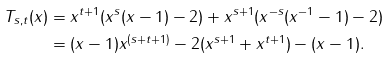Convert formula to latex. <formula><loc_0><loc_0><loc_500><loc_500>T _ { s , t } ( x ) & = x ^ { t + 1 } ( x ^ { s } ( x - 1 ) - 2 ) + x ^ { s + 1 } ( x ^ { - s } ( x ^ { - 1 } - 1 ) - 2 ) \\ & = ( x - 1 ) x ^ { ( s + t + 1 ) } - 2 ( x ^ { s + 1 } + x ^ { t + 1 } ) - ( x - 1 ) .</formula> 